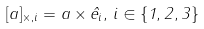<formula> <loc_0><loc_0><loc_500><loc_500>[ a ] _ { \times , i } = a \times { \hat { e } } _ { i } , \, i \in \{ 1 , 2 , 3 \}</formula> 